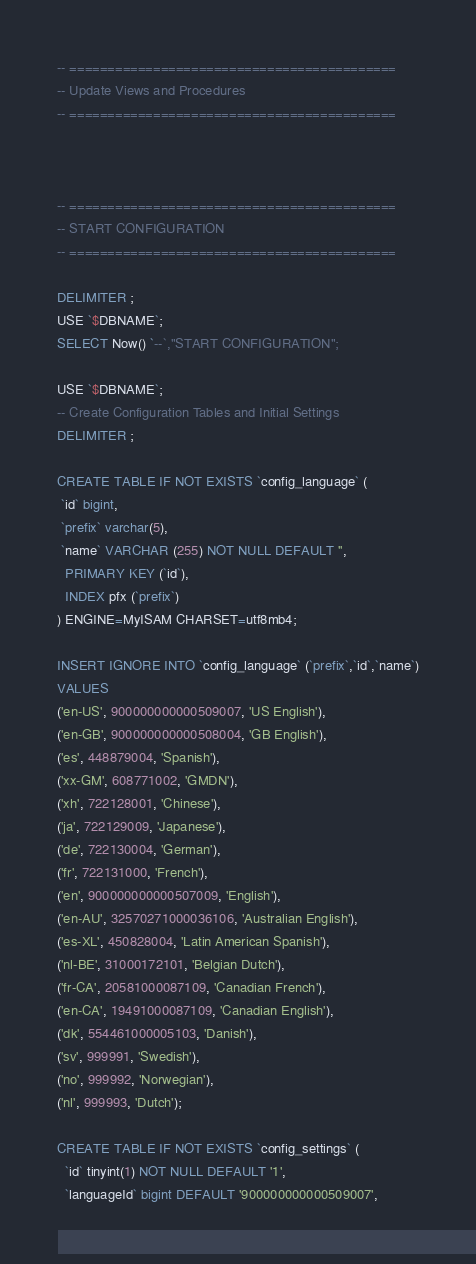<code> <loc_0><loc_0><loc_500><loc_500><_SQL_>

-- ===========================================
-- Update Views and Procedures
-- ===========================================



-- ===========================================
-- START CONFIGURATION
-- ===========================================

DELIMITER ;
USE `$DBNAME`;
SELECT Now() `--`,"START CONFIGURATION";

USE `$DBNAME`;
-- Create Configuration Tables and Initial Settings
DELIMITER ;

CREATE TABLE IF NOT EXISTS `config_language` (
 `id` bigint,
 `prefix` varchar(5),
 `name` VARCHAR (255) NOT NULL DEFAULT '',
  PRIMARY KEY (`id`),
  INDEX pfx (`prefix`)
) ENGINE=MyISAM CHARSET=utf8mb4;

INSERT IGNORE INTO `config_language` (`prefix`,`id`,`name`)
VALUES
('en-US', 900000000000509007, 'US English'),
('en-GB', 900000000000508004, 'GB English'),
('es', 448879004, 'Spanish'),
('xx-GM', 608771002, 'GMDN'),
('xh', 722128001, 'Chinese'),
('ja', 722129009, 'Japanese'),
('de', 722130004, 'German'),
('fr', 722131000, 'French'),
('en', 900000000000507009, 'English'),
('en-AU', 32570271000036106, 'Australian English'),
('es-XL', 450828004, 'Latin American Spanish'),
('nl-BE', 31000172101, 'Belgian Dutch'),
('fr-CA', 20581000087109, 'Canadian French'),
('en-CA', 19491000087109, 'Canadian English'),
('dk', 554461000005103, 'Danish'),
('sv', 999991, 'Swedish'),
('no', 999992, 'Norwegian'),
('nl', 999993, 'Dutch');

CREATE TABLE IF NOT EXISTS `config_settings` (
  `id` tinyint(1) NOT NULL DEFAULT '1',
  `languageId` bigint DEFAULT '900000000000509007',</code> 